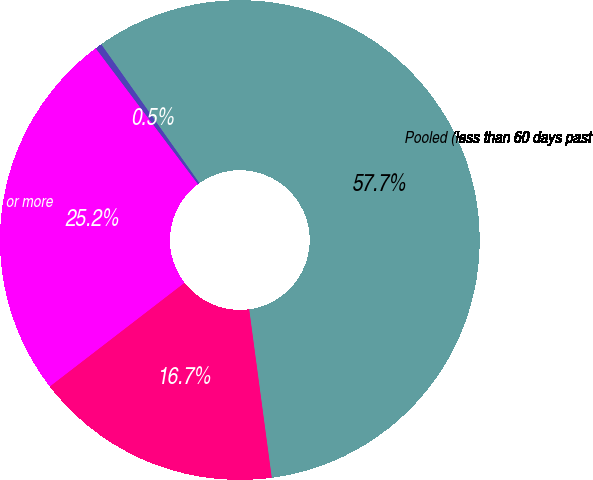<chart> <loc_0><loc_0><loc_500><loc_500><pie_chart><fcel>As of April 30<fcel>Pooled (less than 60 days past<fcel>Individually (TDRs)<fcel>Individually (60 days or more<nl><fcel>0.47%<fcel>57.68%<fcel>16.68%<fcel>25.18%<nl></chart> 